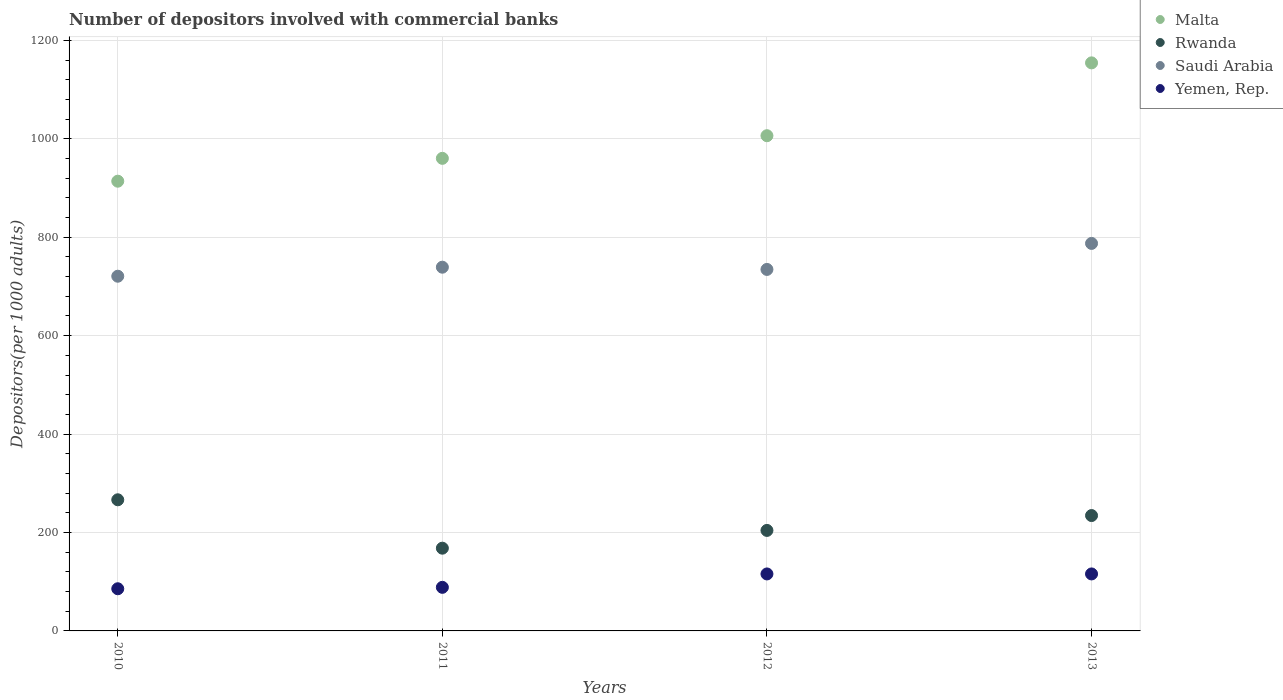What is the number of depositors involved with commercial banks in Yemen, Rep. in 2010?
Provide a succinct answer. 85.68. Across all years, what is the maximum number of depositors involved with commercial banks in Yemen, Rep.?
Offer a very short reply. 115.79. Across all years, what is the minimum number of depositors involved with commercial banks in Malta?
Your response must be concise. 913.8. In which year was the number of depositors involved with commercial banks in Rwanda maximum?
Make the answer very short. 2010. In which year was the number of depositors involved with commercial banks in Saudi Arabia minimum?
Make the answer very short. 2010. What is the total number of depositors involved with commercial banks in Rwanda in the graph?
Provide a short and direct response. 873.2. What is the difference between the number of depositors involved with commercial banks in Malta in 2010 and that in 2012?
Make the answer very short. -92.42. What is the difference between the number of depositors involved with commercial banks in Rwanda in 2011 and the number of depositors involved with commercial banks in Malta in 2012?
Your answer should be very brief. -838.11. What is the average number of depositors involved with commercial banks in Malta per year?
Keep it short and to the point. 1008.62. In the year 2013, what is the difference between the number of depositors involved with commercial banks in Rwanda and number of depositors involved with commercial banks in Saudi Arabia?
Provide a short and direct response. -552.94. In how many years, is the number of depositors involved with commercial banks in Saudi Arabia greater than 200?
Your answer should be very brief. 4. What is the ratio of the number of depositors involved with commercial banks in Yemen, Rep. in 2010 to that in 2012?
Offer a very short reply. 0.74. Is the number of depositors involved with commercial banks in Yemen, Rep. in 2010 less than that in 2011?
Offer a terse response. Yes. What is the difference between the highest and the second highest number of depositors involved with commercial banks in Rwanda?
Offer a terse response. 32.04. What is the difference between the highest and the lowest number of depositors involved with commercial banks in Yemen, Rep.?
Your answer should be compact. 30.11. In how many years, is the number of depositors involved with commercial banks in Saudi Arabia greater than the average number of depositors involved with commercial banks in Saudi Arabia taken over all years?
Your answer should be compact. 1. Is it the case that in every year, the sum of the number of depositors involved with commercial banks in Saudi Arabia and number of depositors involved with commercial banks in Yemen, Rep.  is greater than the sum of number of depositors involved with commercial banks in Malta and number of depositors involved with commercial banks in Rwanda?
Provide a succinct answer. No. Is the number of depositors involved with commercial banks in Yemen, Rep. strictly greater than the number of depositors involved with commercial banks in Rwanda over the years?
Provide a succinct answer. No. How many years are there in the graph?
Keep it short and to the point. 4. Does the graph contain any zero values?
Provide a succinct answer. No. Does the graph contain grids?
Your response must be concise. Yes. How many legend labels are there?
Provide a succinct answer. 4. What is the title of the graph?
Your response must be concise. Number of depositors involved with commercial banks. Does "Iceland" appear as one of the legend labels in the graph?
Offer a very short reply. No. What is the label or title of the Y-axis?
Provide a succinct answer. Depositors(per 1000 adults). What is the Depositors(per 1000 adults) in Malta in 2010?
Your response must be concise. 913.8. What is the Depositors(per 1000 adults) in Rwanda in 2010?
Make the answer very short. 266.46. What is the Depositors(per 1000 adults) in Saudi Arabia in 2010?
Provide a succinct answer. 720.71. What is the Depositors(per 1000 adults) in Yemen, Rep. in 2010?
Keep it short and to the point. 85.68. What is the Depositors(per 1000 adults) in Malta in 2011?
Offer a terse response. 960.23. What is the Depositors(per 1000 adults) of Rwanda in 2011?
Provide a succinct answer. 168.11. What is the Depositors(per 1000 adults) of Saudi Arabia in 2011?
Make the answer very short. 739.05. What is the Depositors(per 1000 adults) of Yemen, Rep. in 2011?
Give a very brief answer. 88.57. What is the Depositors(per 1000 adults) of Malta in 2012?
Make the answer very short. 1006.22. What is the Depositors(per 1000 adults) in Rwanda in 2012?
Provide a succinct answer. 204.22. What is the Depositors(per 1000 adults) of Saudi Arabia in 2012?
Your answer should be very brief. 734.51. What is the Depositors(per 1000 adults) of Yemen, Rep. in 2012?
Give a very brief answer. 115.78. What is the Depositors(per 1000 adults) in Malta in 2013?
Your answer should be compact. 1154.22. What is the Depositors(per 1000 adults) in Rwanda in 2013?
Ensure brevity in your answer.  234.42. What is the Depositors(per 1000 adults) in Saudi Arabia in 2013?
Ensure brevity in your answer.  787.36. What is the Depositors(per 1000 adults) in Yemen, Rep. in 2013?
Your answer should be compact. 115.79. Across all years, what is the maximum Depositors(per 1000 adults) in Malta?
Make the answer very short. 1154.22. Across all years, what is the maximum Depositors(per 1000 adults) in Rwanda?
Offer a very short reply. 266.46. Across all years, what is the maximum Depositors(per 1000 adults) in Saudi Arabia?
Ensure brevity in your answer.  787.36. Across all years, what is the maximum Depositors(per 1000 adults) in Yemen, Rep.?
Offer a terse response. 115.79. Across all years, what is the minimum Depositors(per 1000 adults) of Malta?
Provide a succinct answer. 913.8. Across all years, what is the minimum Depositors(per 1000 adults) of Rwanda?
Keep it short and to the point. 168.11. Across all years, what is the minimum Depositors(per 1000 adults) of Saudi Arabia?
Provide a short and direct response. 720.71. Across all years, what is the minimum Depositors(per 1000 adults) of Yemen, Rep.?
Ensure brevity in your answer.  85.68. What is the total Depositors(per 1000 adults) of Malta in the graph?
Provide a succinct answer. 4034.47. What is the total Depositors(per 1000 adults) in Rwanda in the graph?
Make the answer very short. 873.2. What is the total Depositors(per 1000 adults) in Saudi Arabia in the graph?
Keep it short and to the point. 2981.63. What is the total Depositors(per 1000 adults) in Yemen, Rep. in the graph?
Your response must be concise. 405.82. What is the difference between the Depositors(per 1000 adults) of Malta in 2010 and that in 2011?
Your answer should be compact. -46.43. What is the difference between the Depositors(per 1000 adults) in Rwanda in 2010 and that in 2011?
Give a very brief answer. 98.35. What is the difference between the Depositors(per 1000 adults) in Saudi Arabia in 2010 and that in 2011?
Offer a terse response. -18.33. What is the difference between the Depositors(per 1000 adults) of Yemen, Rep. in 2010 and that in 2011?
Make the answer very short. -2.89. What is the difference between the Depositors(per 1000 adults) of Malta in 2010 and that in 2012?
Ensure brevity in your answer.  -92.42. What is the difference between the Depositors(per 1000 adults) of Rwanda in 2010 and that in 2012?
Your response must be concise. 62.24. What is the difference between the Depositors(per 1000 adults) in Saudi Arabia in 2010 and that in 2012?
Keep it short and to the point. -13.8. What is the difference between the Depositors(per 1000 adults) in Yemen, Rep. in 2010 and that in 2012?
Provide a short and direct response. -30.1. What is the difference between the Depositors(per 1000 adults) of Malta in 2010 and that in 2013?
Provide a succinct answer. -240.42. What is the difference between the Depositors(per 1000 adults) in Rwanda in 2010 and that in 2013?
Your response must be concise. 32.04. What is the difference between the Depositors(per 1000 adults) of Saudi Arabia in 2010 and that in 2013?
Provide a short and direct response. -66.64. What is the difference between the Depositors(per 1000 adults) of Yemen, Rep. in 2010 and that in 2013?
Offer a terse response. -30.11. What is the difference between the Depositors(per 1000 adults) in Malta in 2011 and that in 2012?
Your answer should be very brief. -45.99. What is the difference between the Depositors(per 1000 adults) in Rwanda in 2011 and that in 2012?
Your answer should be compact. -36.1. What is the difference between the Depositors(per 1000 adults) of Saudi Arabia in 2011 and that in 2012?
Keep it short and to the point. 4.54. What is the difference between the Depositors(per 1000 adults) in Yemen, Rep. in 2011 and that in 2012?
Ensure brevity in your answer.  -27.21. What is the difference between the Depositors(per 1000 adults) in Malta in 2011 and that in 2013?
Make the answer very short. -193.99. What is the difference between the Depositors(per 1000 adults) in Rwanda in 2011 and that in 2013?
Ensure brevity in your answer.  -66.31. What is the difference between the Depositors(per 1000 adults) of Saudi Arabia in 2011 and that in 2013?
Offer a very short reply. -48.31. What is the difference between the Depositors(per 1000 adults) in Yemen, Rep. in 2011 and that in 2013?
Offer a terse response. -27.22. What is the difference between the Depositors(per 1000 adults) of Malta in 2012 and that in 2013?
Give a very brief answer. -148. What is the difference between the Depositors(per 1000 adults) of Rwanda in 2012 and that in 2013?
Make the answer very short. -30.2. What is the difference between the Depositors(per 1000 adults) of Saudi Arabia in 2012 and that in 2013?
Give a very brief answer. -52.85. What is the difference between the Depositors(per 1000 adults) of Yemen, Rep. in 2012 and that in 2013?
Your response must be concise. -0.01. What is the difference between the Depositors(per 1000 adults) in Malta in 2010 and the Depositors(per 1000 adults) in Rwanda in 2011?
Provide a short and direct response. 745.69. What is the difference between the Depositors(per 1000 adults) in Malta in 2010 and the Depositors(per 1000 adults) in Saudi Arabia in 2011?
Give a very brief answer. 174.75. What is the difference between the Depositors(per 1000 adults) of Malta in 2010 and the Depositors(per 1000 adults) of Yemen, Rep. in 2011?
Provide a succinct answer. 825.23. What is the difference between the Depositors(per 1000 adults) of Rwanda in 2010 and the Depositors(per 1000 adults) of Saudi Arabia in 2011?
Provide a short and direct response. -472.59. What is the difference between the Depositors(per 1000 adults) of Rwanda in 2010 and the Depositors(per 1000 adults) of Yemen, Rep. in 2011?
Give a very brief answer. 177.89. What is the difference between the Depositors(per 1000 adults) of Saudi Arabia in 2010 and the Depositors(per 1000 adults) of Yemen, Rep. in 2011?
Offer a terse response. 632.14. What is the difference between the Depositors(per 1000 adults) in Malta in 2010 and the Depositors(per 1000 adults) in Rwanda in 2012?
Ensure brevity in your answer.  709.58. What is the difference between the Depositors(per 1000 adults) in Malta in 2010 and the Depositors(per 1000 adults) in Saudi Arabia in 2012?
Your answer should be compact. 179.29. What is the difference between the Depositors(per 1000 adults) in Malta in 2010 and the Depositors(per 1000 adults) in Yemen, Rep. in 2012?
Ensure brevity in your answer.  798.02. What is the difference between the Depositors(per 1000 adults) of Rwanda in 2010 and the Depositors(per 1000 adults) of Saudi Arabia in 2012?
Your answer should be compact. -468.05. What is the difference between the Depositors(per 1000 adults) of Rwanda in 2010 and the Depositors(per 1000 adults) of Yemen, Rep. in 2012?
Provide a short and direct response. 150.67. What is the difference between the Depositors(per 1000 adults) in Saudi Arabia in 2010 and the Depositors(per 1000 adults) in Yemen, Rep. in 2012?
Offer a very short reply. 604.93. What is the difference between the Depositors(per 1000 adults) of Malta in 2010 and the Depositors(per 1000 adults) of Rwanda in 2013?
Make the answer very short. 679.38. What is the difference between the Depositors(per 1000 adults) of Malta in 2010 and the Depositors(per 1000 adults) of Saudi Arabia in 2013?
Keep it short and to the point. 126.44. What is the difference between the Depositors(per 1000 adults) of Malta in 2010 and the Depositors(per 1000 adults) of Yemen, Rep. in 2013?
Provide a succinct answer. 798.01. What is the difference between the Depositors(per 1000 adults) in Rwanda in 2010 and the Depositors(per 1000 adults) in Saudi Arabia in 2013?
Your response must be concise. -520.9. What is the difference between the Depositors(per 1000 adults) in Rwanda in 2010 and the Depositors(per 1000 adults) in Yemen, Rep. in 2013?
Provide a succinct answer. 150.67. What is the difference between the Depositors(per 1000 adults) in Saudi Arabia in 2010 and the Depositors(per 1000 adults) in Yemen, Rep. in 2013?
Your answer should be very brief. 604.92. What is the difference between the Depositors(per 1000 adults) in Malta in 2011 and the Depositors(per 1000 adults) in Rwanda in 2012?
Make the answer very short. 756.01. What is the difference between the Depositors(per 1000 adults) in Malta in 2011 and the Depositors(per 1000 adults) in Saudi Arabia in 2012?
Offer a terse response. 225.72. What is the difference between the Depositors(per 1000 adults) of Malta in 2011 and the Depositors(per 1000 adults) of Yemen, Rep. in 2012?
Provide a short and direct response. 844.45. What is the difference between the Depositors(per 1000 adults) of Rwanda in 2011 and the Depositors(per 1000 adults) of Saudi Arabia in 2012?
Offer a very short reply. -566.4. What is the difference between the Depositors(per 1000 adults) of Rwanda in 2011 and the Depositors(per 1000 adults) of Yemen, Rep. in 2012?
Your answer should be very brief. 52.33. What is the difference between the Depositors(per 1000 adults) in Saudi Arabia in 2011 and the Depositors(per 1000 adults) in Yemen, Rep. in 2012?
Offer a terse response. 623.26. What is the difference between the Depositors(per 1000 adults) in Malta in 2011 and the Depositors(per 1000 adults) in Rwanda in 2013?
Offer a terse response. 725.81. What is the difference between the Depositors(per 1000 adults) in Malta in 2011 and the Depositors(per 1000 adults) in Saudi Arabia in 2013?
Offer a very short reply. 172.87. What is the difference between the Depositors(per 1000 adults) of Malta in 2011 and the Depositors(per 1000 adults) of Yemen, Rep. in 2013?
Your response must be concise. 844.44. What is the difference between the Depositors(per 1000 adults) of Rwanda in 2011 and the Depositors(per 1000 adults) of Saudi Arabia in 2013?
Give a very brief answer. -619.25. What is the difference between the Depositors(per 1000 adults) in Rwanda in 2011 and the Depositors(per 1000 adults) in Yemen, Rep. in 2013?
Your answer should be compact. 52.32. What is the difference between the Depositors(per 1000 adults) in Saudi Arabia in 2011 and the Depositors(per 1000 adults) in Yemen, Rep. in 2013?
Provide a short and direct response. 623.26. What is the difference between the Depositors(per 1000 adults) of Malta in 2012 and the Depositors(per 1000 adults) of Rwanda in 2013?
Offer a very short reply. 771.8. What is the difference between the Depositors(per 1000 adults) of Malta in 2012 and the Depositors(per 1000 adults) of Saudi Arabia in 2013?
Your response must be concise. 218.86. What is the difference between the Depositors(per 1000 adults) in Malta in 2012 and the Depositors(per 1000 adults) in Yemen, Rep. in 2013?
Give a very brief answer. 890.43. What is the difference between the Depositors(per 1000 adults) in Rwanda in 2012 and the Depositors(per 1000 adults) in Saudi Arabia in 2013?
Offer a very short reply. -583.14. What is the difference between the Depositors(per 1000 adults) of Rwanda in 2012 and the Depositors(per 1000 adults) of Yemen, Rep. in 2013?
Offer a terse response. 88.43. What is the difference between the Depositors(per 1000 adults) of Saudi Arabia in 2012 and the Depositors(per 1000 adults) of Yemen, Rep. in 2013?
Make the answer very short. 618.72. What is the average Depositors(per 1000 adults) in Malta per year?
Provide a succinct answer. 1008.62. What is the average Depositors(per 1000 adults) in Rwanda per year?
Offer a very short reply. 218.3. What is the average Depositors(per 1000 adults) of Saudi Arabia per year?
Your answer should be compact. 745.41. What is the average Depositors(per 1000 adults) of Yemen, Rep. per year?
Your answer should be compact. 101.46. In the year 2010, what is the difference between the Depositors(per 1000 adults) in Malta and Depositors(per 1000 adults) in Rwanda?
Keep it short and to the point. 647.34. In the year 2010, what is the difference between the Depositors(per 1000 adults) in Malta and Depositors(per 1000 adults) in Saudi Arabia?
Your answer should be compact. 193.09. In the year 2010, what is the difference between the Depositors(per 1000 adults) of Malta and Depositors(per 1000 adults) of Yemen, Rep.?
Ensure brevity in your answer.  828.12. In the year 2010, what is the difference between the Depositors(per 1000 adults) in Rwanda and Depositors(per 1000 adults) in Saudi Arabia?
Your response must be concise. -454.26. In the year 2010, what is the difference between the Depositors(per 1000 adults) of Rwanda and Depositors(per 1000 adults) of Yemen, Rep.?
Make the answer very short. 180.77. In the year 2010, what is the difference between the Depositors(per 1000 adults) of Saudi Arabia and Depositors(per 1000 adults) of Yemen, Rep.?
Offer a terse response. 635.03. In the year 2011, what is the difference between the Depositors(per 1000 adults) in Malta and Depositors(per 1000 adults) in Rwanda?
Your answer should be compact. 792.12. In the year 2011, what is the difference between the Depositors(per 1000 adults) of Malta and Depositors(per 1000 adults) of Saudi Arabia?
Make the answer very short. 221.18. In the year 2011, what is the difference between the Depositors(per 1000 adults) of Malta and Depositors(per 1000 adults) of Yemen, Rep.?
Your answer should be compact. 871.66. In the year 2011, what is the difference between the Depositors(per 1000 adults) of Rwanda and Depositors(per 1000 adults) of Saudi Arabia?
Ensure brevity in your answer.  -570.94. In the year 2011, what is the difference between the Depositors(per 1000 adults) in Rwanda and Depositors(per 1000 adults) in Yemen, Rep.?
Keep it short and to the point. 79.54. In the year 2011, what is the difference between the Depositors(per 1000 adults) of Saudi Arabia and Depositors(per 1000 adults) of Yemen, Rep.?
Offer a very short reply. 650.48. In the year 2012, what is the difference between the Depositors(per 1000 adults) in Malta and Depositors(per 1000 adults) in Rwanda?
Keep it short and to the point. 802.01. In the year 2012, what is the difference between the Depositors(per 1000 adults) in Malta and Depositors(per 1000 adults) in Saudi Arabia?
Make the answer very short. 271.71. In the year 2012, what is the difference between the Depositors(per 1000 adults) in Malta and Depositors(per 1000 adults) in Yemen, Rep.?
Your answer should be very brief. 890.44. In the year 2012, what is the difference between the Depositors(per 1000 adults) in Rwanda and Depositors(per 1000 adults) in Saudi Arabia?
Offer a very short reply. -530.3. In the year 2012, what is the difference between the Depositors(per 1000 adults) of Rwanda and Depositors(per 1000 adults) of Yemen, Rep.?
Give a very brief answer. 88.43. In the year 2012, what is the difference between the Depositors(per 1000 adults) of Saudi Arabia and Depositors(per 1000 adults) of Yemen, Rep.?
Keep it short and to the point. 618.73. In the year 2013, what is the difference between the Depositors(per 1000 adults) in Malta and Depositors(per 1000 adults) in Rwanda?
Offer a terse response. 919.8. In the year 2013, what is the difference between the Depositors(per 1000 adults) in Malta and Depositors(per 1000 adults) in Saudi Arabia?
Your answer should be very brief. 366.86. In the year 2013, what is the difference between the Depositors(per 1000 adults) in Malta and Depositors(per 1000 adults) in Yemen, Rep.?
Make the answer very short. 1038.43. In the year 2013, what is the difference between the Depositors(per 1000 adults) of Rwanda and Depositors(per 1000 adults) of Saudi Arabia?
Provide a short and direct response. -552.94. In the year 2013, what is the difference between the Depositors(per 1000 adults) of Rwanda and Depositors(per 1000 adults) of Yemen, Rep.?
Offer a terse response. 118.63. In the year 2013, what is the difference between the Depositors(per 1000 adults) in Saudi Arabia and Depositors(per 1000 adults) in Yemen, Rep.?
Keep it short and to the point. 671.57. What is the ratio of the Depositors(per 1000 adults) of Malta in 2010 to that in 2011?
Give a very brief answer. 0.95. What is the ratio of the Depositors(per 1000 adults) in Rwanda in 2010 to that in 2011?
Offer a very short reply. 1.58. What is the ratio of the Depositors(per 1000 adults) in Saudi Arabia in 2010 to that in 2011?
Offer a terse response. 0.98. What is the ratio of the Depositors(per 1000 adults) in Yemen, Rep. in 2010 to that in 2011?
Provide a succinct answer. 0.97. What is the ratio of the Depositors(per 1000 adults) of Malta in 2010 to that in 2012?
Your answer should be compact. 0.91. What is the ratio of the Depositors(per 1000 adults) of Rwanda in 2010 to that in 2012?
Your answer should be very brief. 1.3. What is the ratio of the Depositors(per 1000 adults) in Saudi Arabia in 2010 to that in 2012?
Offer a terse response. 0.98. What is the ratio of the Depositors(per 1000 adults) in Yemen, Rep. in 2010 to that in 2012?
Make the answer very short. 0.74. What is the ratio of the Depositors(per 1000 adults) in Malta in 2010 to that in 2013?
Offer a very short reply. 0.79. What is the ratio of the Depositors(per 1000 adults) of Rwanda in 2010 to that in 2013?
Ensure brevity in your answer.  1.14. What is the ratio of the Depositors(per 1000 adults) in Saudi Arabia in 2010 to that in 2013?
Give a very brief answer. 0.92. What is the ratio of the Depositors(per 1000 adults) in Yemen, Rep. in 2010 to that in 2013?
Provide a short and direct response. 0.74. What is the ratio of the Depositors(per 1000 adults) in Malta in 2011 to that in 2012?
Provide a succinct answer. 0.95. What is the ratio of the Depositors(per 1000 adults) in Rwanda in 2011 to that in 2012?
Provide a short and direct response. 0.82. What is the ratio of the Depositors(per 1000 adults) in Yemen, Rep. in 2011 to that in 2012?
Make the answer very short. 0.77. What is the ratio of the Depositors(per 1000 adults) of Malta in 2011 to that in 2013?
Ensure brevity in your answer.  0.83. What is the ratio of the Depositors(per 1000 adults) in Rwanda in 2011 to that in 2013?
Ensure brevity in your answer.  0.72. What is the ratio of the Depositors(per 1000 adults) in Saudi Arabia in 2011 to that in 2013?
Provide a short and direct response. 0.94. What is the ratio of the Depositors(per 1000 adults) in Yemen, Rep. in 2011 to that in 2013?
Your answer should be very brief. 0.76. What is the ratio of the Depositors(per 1000 adults) of Malta in 2012 to that in 2013?
Provide a succinct answer. 0.87. What is the ratio of the Depositors(per 1000 adults) of Rwanda in 2012 to that in 2013?
Offer a very short reply. 0.87. What is the ratio of the Depositors(per 1000 adults) of Saudi Arabia in 2012 to that in 2013?
Ensure brevity in your answer.  0.93. What is the ratio of the Depositors(per 1000 adults) in Yemen, Rep. in 2012 to that in 2013?
Your response must be concise. 1. What is the difference between the highest and the second highest Depositors(per 1000 adults) of Malta?
Your answer should be compact. 148. What is the difference between the highest and the second highest Depositors(per 1000 adults) of Rwanda?
Your answer should be compact. 32.04. What is the difference between the highest and the second highest Depositors(per 1000 adults) of Saudi Arabia?
Ensure brevity in your answer.  48.31. What is the difference between the highest and the second highest Depositors(per 1000 adults) of Yemen, Rep.?
Make the answer very short. 0.01. What is the difference between the highest and the lowest Depositors(per 1000 adults) in Malta?
Keep it short and to the point. 240.42. What is the difference between the highest and the lowest Depositors(per 1000 adults) in Rwanda?
Offer a very short reply. 98.35. What is the difference between the highest and the lowest Depositors(per 1000 adults) of Saudi Arabia?
Give a very brief answer. 66.64. What is the difference between the highest and the lowest Depositors(per 1000 adults) of Yemen, Rep.?
Make the answer very short. 30.11. 